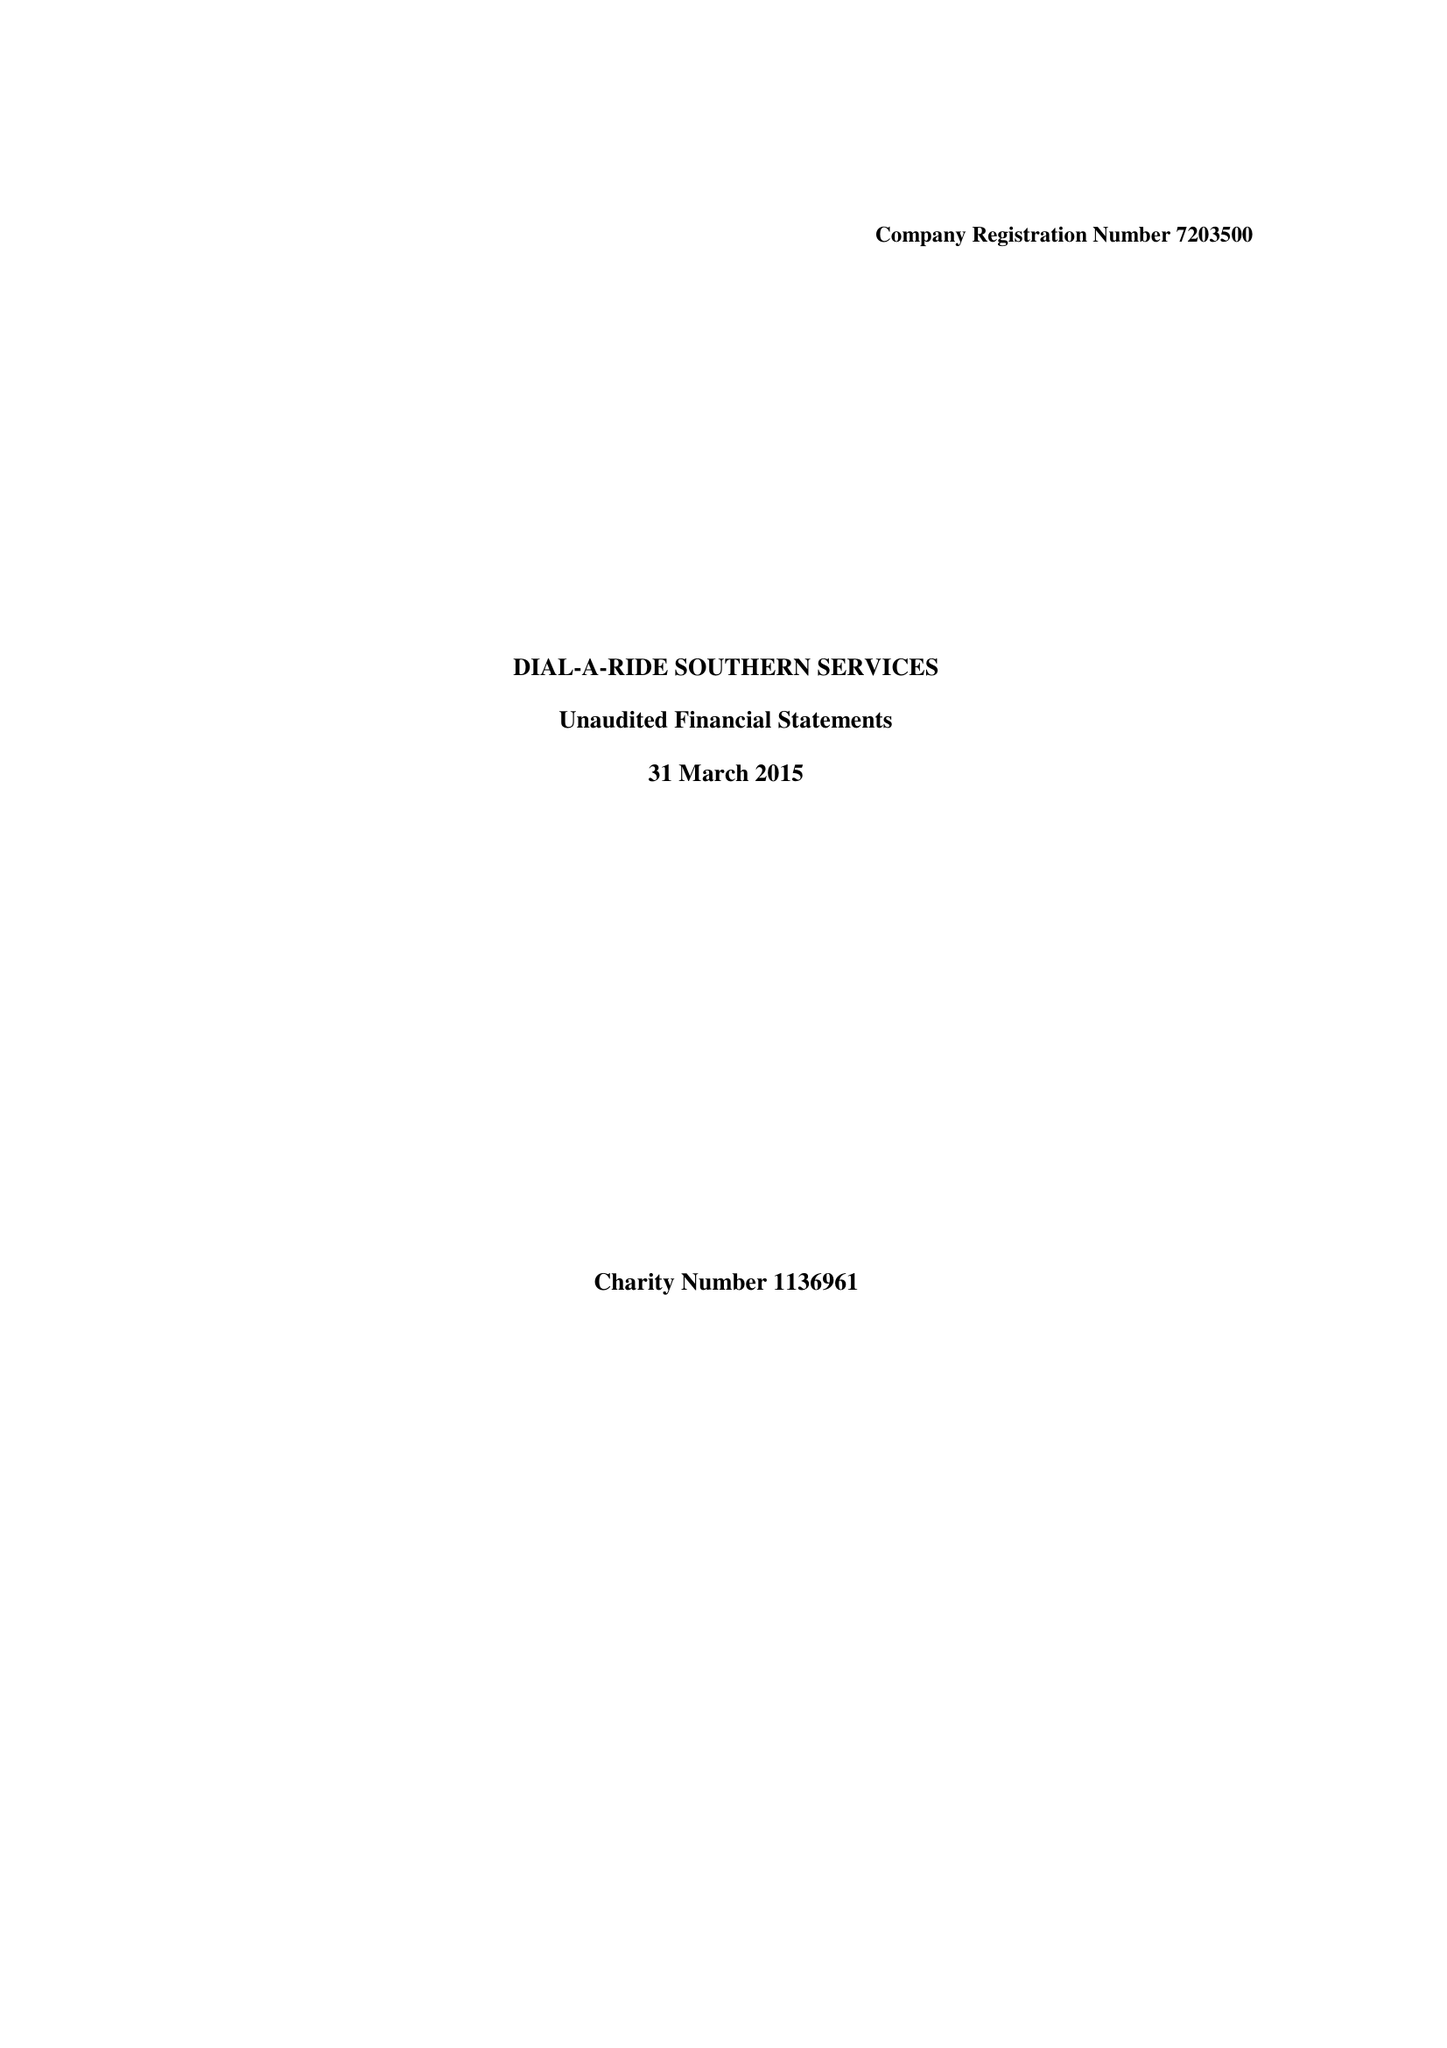What is the value for the address__street_line?
Answer the question using a single word or phrase. RALEIGH WAY 